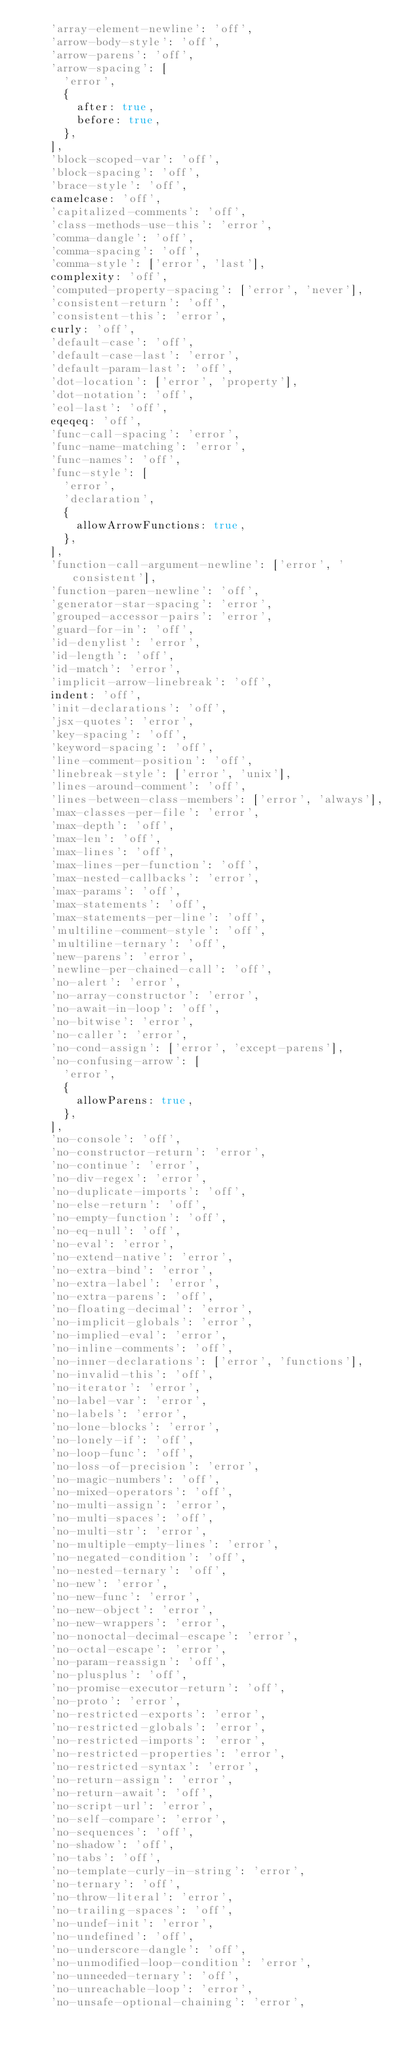Convert code to text. <code><loc_0><loc_0><loc_500><loc_500><_JavaScript_>		'array-element-newline': 'off',
		'arrow-body-style': 'off',
		'arrow-parens': 'off',
		'arrow-spacing': [
			'error',
			{
				after: true,
				before: true,
			},
		],
		'block-scoped-var': 'off',
		'block-spacing': 'off',
		'brace-style': 'off',
		camelcase: 'off',
		'capitalized-comments': 'off',
		'class-methods-use-this': 'error',
		'comma-dangle': 'off',
		'comma-spacing': 'off',
		'comma-style': ['error', 'last'],
		complexity: 'off',
		'computed-property-spacing': ['error', 'never'],
		'consistent-return': 'off',
		'consistent-this': 'error',
		curly: 'off',
		'default-case': 'off',
		'default-case-last': 'error',
		'default-param-last': 'off',
		'dot-location': ['error', 'property'],
		'dot-notation': 'off',
		'eol-last': 'off',
		eqeqeq: 'off',
		'func-call-spacing': 'error',
		'func-name-matching': 'error',
		'func-names': 'off',
		'func-style': [
			'error',
			'declaration',
			{
				allowArrowFunctions: true,
			},
		],
		'function-call-argument-newline': ['error', 'consistent'],
		'function-paren-newline': 'off',
		'generator-star-spacing': 'error',
		'grouped-accessor-pairs': 'error',
		'guard-for-in': 'off',
		'id-denylist': 'error',
		'id-length': 'off',
		'id-match': 'error',
		'implicit-arrow-linebreak': 'off',
		indent: 'off',
		'init-declarations': 'off',
		'jsx-quotes': 'error',
		'key-spacing': 'off',
		'keyword-spacing': 'off',
		'line-comment-position': 'off',
		'linebreak-style': ['error', 'unix'],
		'lines-around-comment': 'off',
		'lines-between-class-members': ['error', 'always'],
		'max-classes-per-file': 'error',
		'max-depth': 'off',
		'max-len': 'off',
		'max-lines': 'off',
		'max-lines-per-function': 'off',
		'max-nested-callbacks': 'error',
		'max-params': 'off',
		'max-statements': 'off',
		'max-statements-per-line': 'off',
		'multiline-comment-style': 'off',
		'multiline-ternary': 'off',
		'new-parens': 'error',
		'newline-per-chained-call': 'off',
		'no-alert': 'error',
		'no-array-constructor': 'error',
		'no-await-in-loop': 'off',
		'no-bitwise': 'error',
		'no-caller': 'error',
		'no-cond-assign': ['error', 'except-parens'],
		'no-confusing-arrow': [
			'error',
			{
				allowParens: true,
			},
		],
		'no-console': 'off',
		'no-constructor-return': 'error',
		'no-continue': 'error',
		'no-div-regex': 'error',
		'no-duplicate-imports': 'off',
		'no-else-return': 'off',
		'no-empty-function': 'off',
		'no-eq-null': 'off',
		'no-eval': 'error',
		'no-extend-native': 'error',
		'no-extra-bind': 'error',
		'no-extra-label': 'error',
		'no-extra-parens': 'off',
		'no-floating-decimal': 'error',
		'no-implicit-globals': 'error',
		'no-implied-eval': 'error',
		'no-inline-comments': 'off',
		'no-inner-declarations': ['error', 'functions'],
		'no-invalid-this': 'off',
		'no-iterator': 'error',
		'no-label-var': 'error',
		'no-labels': 'error',
		'no-lone-blocks': 'error',
		'no-lonely-if': 'off',
		'no-loop-func': 'off',
		'no-loss-of-precision': 'error',
		'no-magic-numbers': 'off',
		'no-mixed-operators': 'off',
		'no-multi-assign': 'error',
		'no-multi-spaces': 'off',
		'no-multi-str': 'error',
		'no-multiple-empty-lines': 'error',
		'no-negated-condition': 'off',
		'no-nested-ternary': 'off',
		'no-new': 'error',
		'no-new-func': 'error',
		'no-new-object': 'error',
		'no-new-wrappers': 'error',
		'no-nonoctal-decimal-escape': 'error',
		'no-octal-escape': 'error',
		'no-param-reassign': 'off',
		'no-plusplus': 'off',
		'no-promise-executor-return': 'off',
		'no-proto': 'error',
		'no-restricted-exports': 'error',
		'no-restricted-globals': 'error',
		'no-restricted-imports': 'error',
		'no-restricted-properties': 'error',
		'no-restricted-syntax': 'error',
		'no-return-assign': 'error',
		'no-return-await': 'off',
		'no-script-url': 'error',
		'no-self-compare': 'error',
		'no-sequences': 'off',
		'no-shadow': 'off',
		'no-tabs': 'off',
		'no-template-curly-in-string': 'error',
		'no-ternary': 'off',
		'no-throw-literal': 'error',
		'no-trailing-spaces': 'off',
		'no-undef-init': 'error',
		'no-undefined': 'off',
		'no-underscore-dangle': 'off',
		'no-unmodified-loop-condition': 'error',
		'no-unneeded-ternary': 'off',
		'no-unreachable-loop': 'error',
		'no-unsafe-optional-chaining': 'error',</code> 